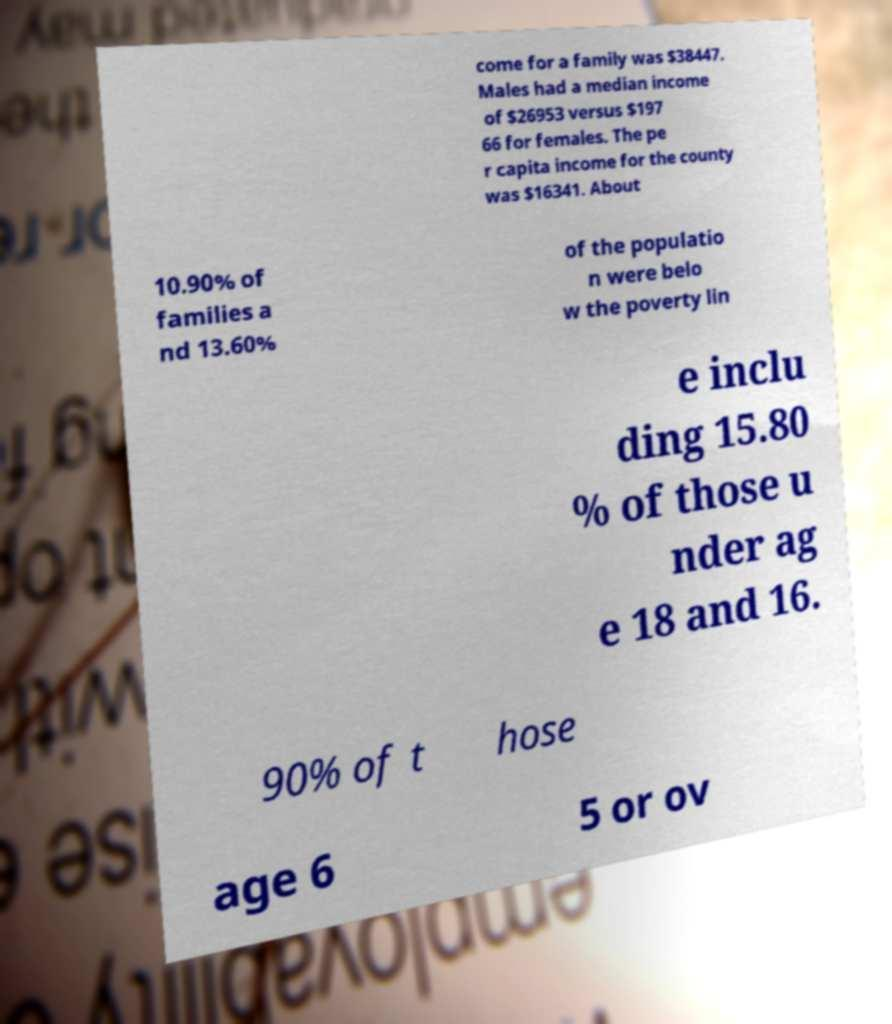Could you assist in decoding the text presented in this image and type it out clearly? come for a family was $38447. Males had a median income of $26953 versus $197 66 for females. The pe r capita income for the county was $16341. About 10.90% of families a nd 13.60% of the populatio n were belo w the poverty lin e inclu ding 15.80 % of those u nder ag e 18 and 16. 90% of t hose age 6 5 or ov 